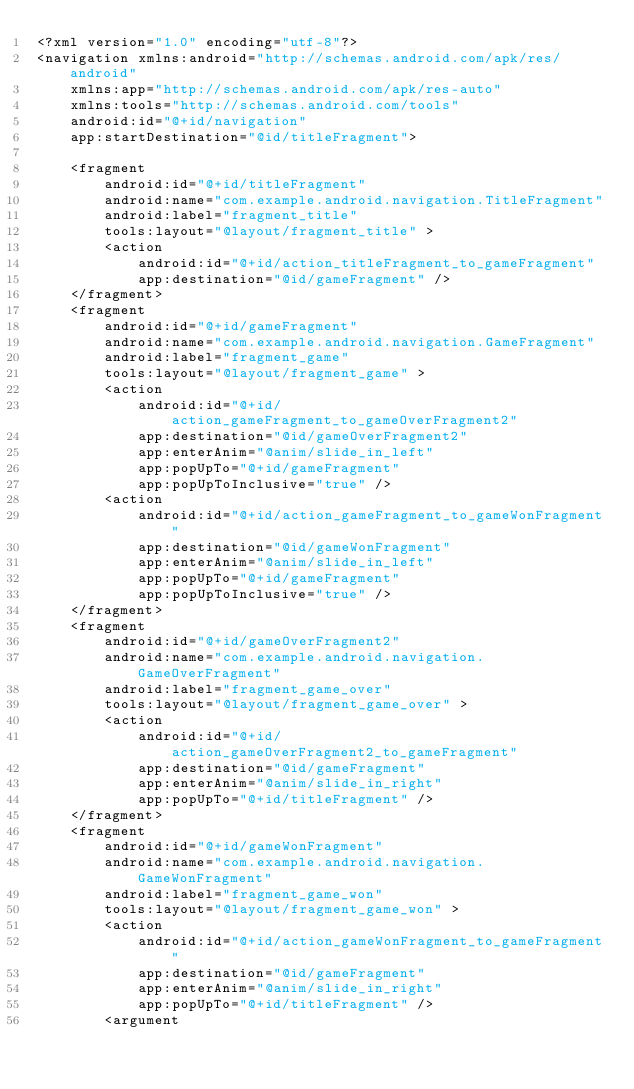Convert code to text. <code><loc_0><loc_0><loc_500><loc_500><_XML_><?xml version="1.0" encoding="utf-8"?>
<navigation xmlns:android="http://schemas.android.com/apk/res/android"
    xmlns:app="http://schemas.android.com/apk/res-auto"
    xmlns:tools="http://schemas.android.com/tools"
    android:id="@+id/navigation"
    app:startDestination="@id/titleFragment">

    <fragment
        android:id="@+id/titleFragment"
        android:name="com.example.android.navigation.TitleFragment"
        android:label="fragment_title"
        tools:layout="@layout/fragment_title" >
        <action
            android:id="@+id/action_titleFragment_to_gameFragment"
            app:destination="@id/gameFragment" />
    </fragment>
    <fragment
        android:id="@+id/gameFragment"
        android:name="com.example.android.navigation.GameFragment"
        android:label="fragment_game"
        tools:layout="@layout/fragment_game" >
        <action
            android:id="@+id/action_gameFragment_to_gameOverFragment2"
            app:destination="@id/gameOverFragment2"
            app:enterAnim="@anim/slide_in_left"
            app:popUpTo="@+id/gameFragment"
            app:popUpToInclusive="true" />
        <action
            android:id="@+id/action_gameFragment_to_gameWonFragment"
            app:destination="@id/gameWonFragment"
            app:enterAnim="@anim/slide_in_left"
            app:popUpTo="@+id/gameFragment"
            app:popUpToInclusive="true" />
    </fragment>
    <fragment
        android:id="@+id/gameOverFragment2"
        android:name="com.example.android.navigation.GameOverFragment"
        android:label="fragment_game_over"
        tools:layout="@layout/fragment_game_over" >
        <action
            android:id="@+id/action_gameOverFragment2_to_gameFragment"
            app:destination="@id/gameFragment"
            app:enterAnim="@anim/slide_in_right"
            app:popUpTo="@+id/titleFragment" />
    </fragment>
    <fragment
        android:id="@+id/gameWonFragment"
        android:name="com.example.android.navigation.GameWonFragment"
        android:label="fragment_game_won"
        tools:layout="@layout/fragment_game_won" >
        <action
            android:id="@+id/action_gameWonFragment_to_gameFragment"
            app:destination="@id/gameFragment"
            app:enterAnim="@anim/slide_in_right"
            app:popUpTo="@+id/titleFragment" />
        <argument</code> 